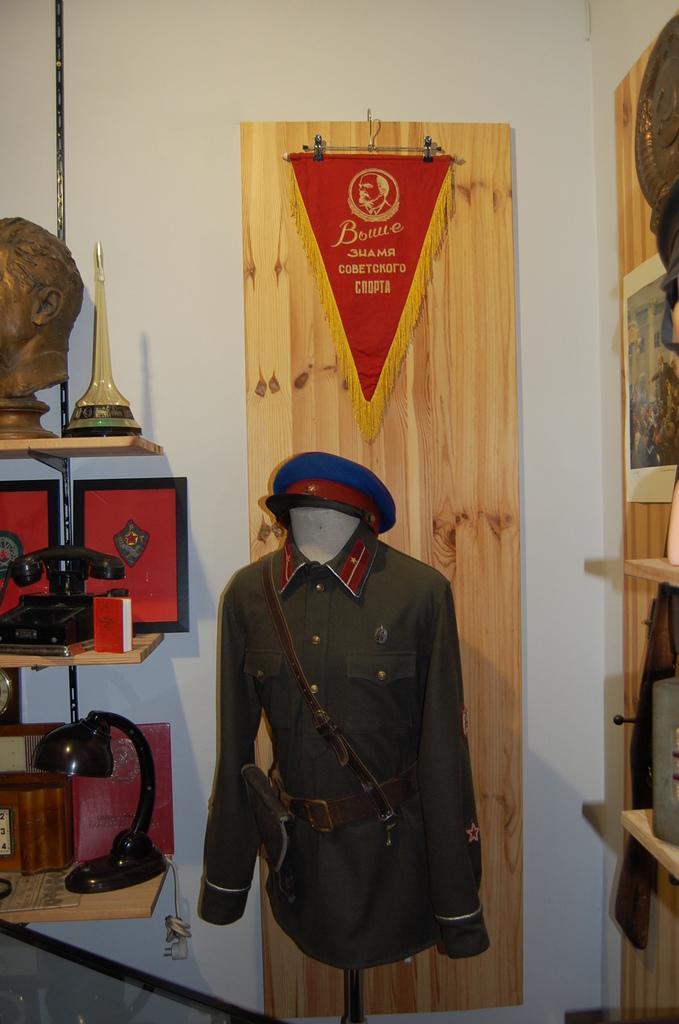Please provide a concise description of this image. In the middle of this image, there is a cap attached to a uniform. On the left side, there is a light, a telephone, a memento, a box and other objects arranged on the shelves. On the right side, there is a cupboard. In the background, there is a red color flag attached to a wooden surface. This wooden surface is attached to a white wall. 